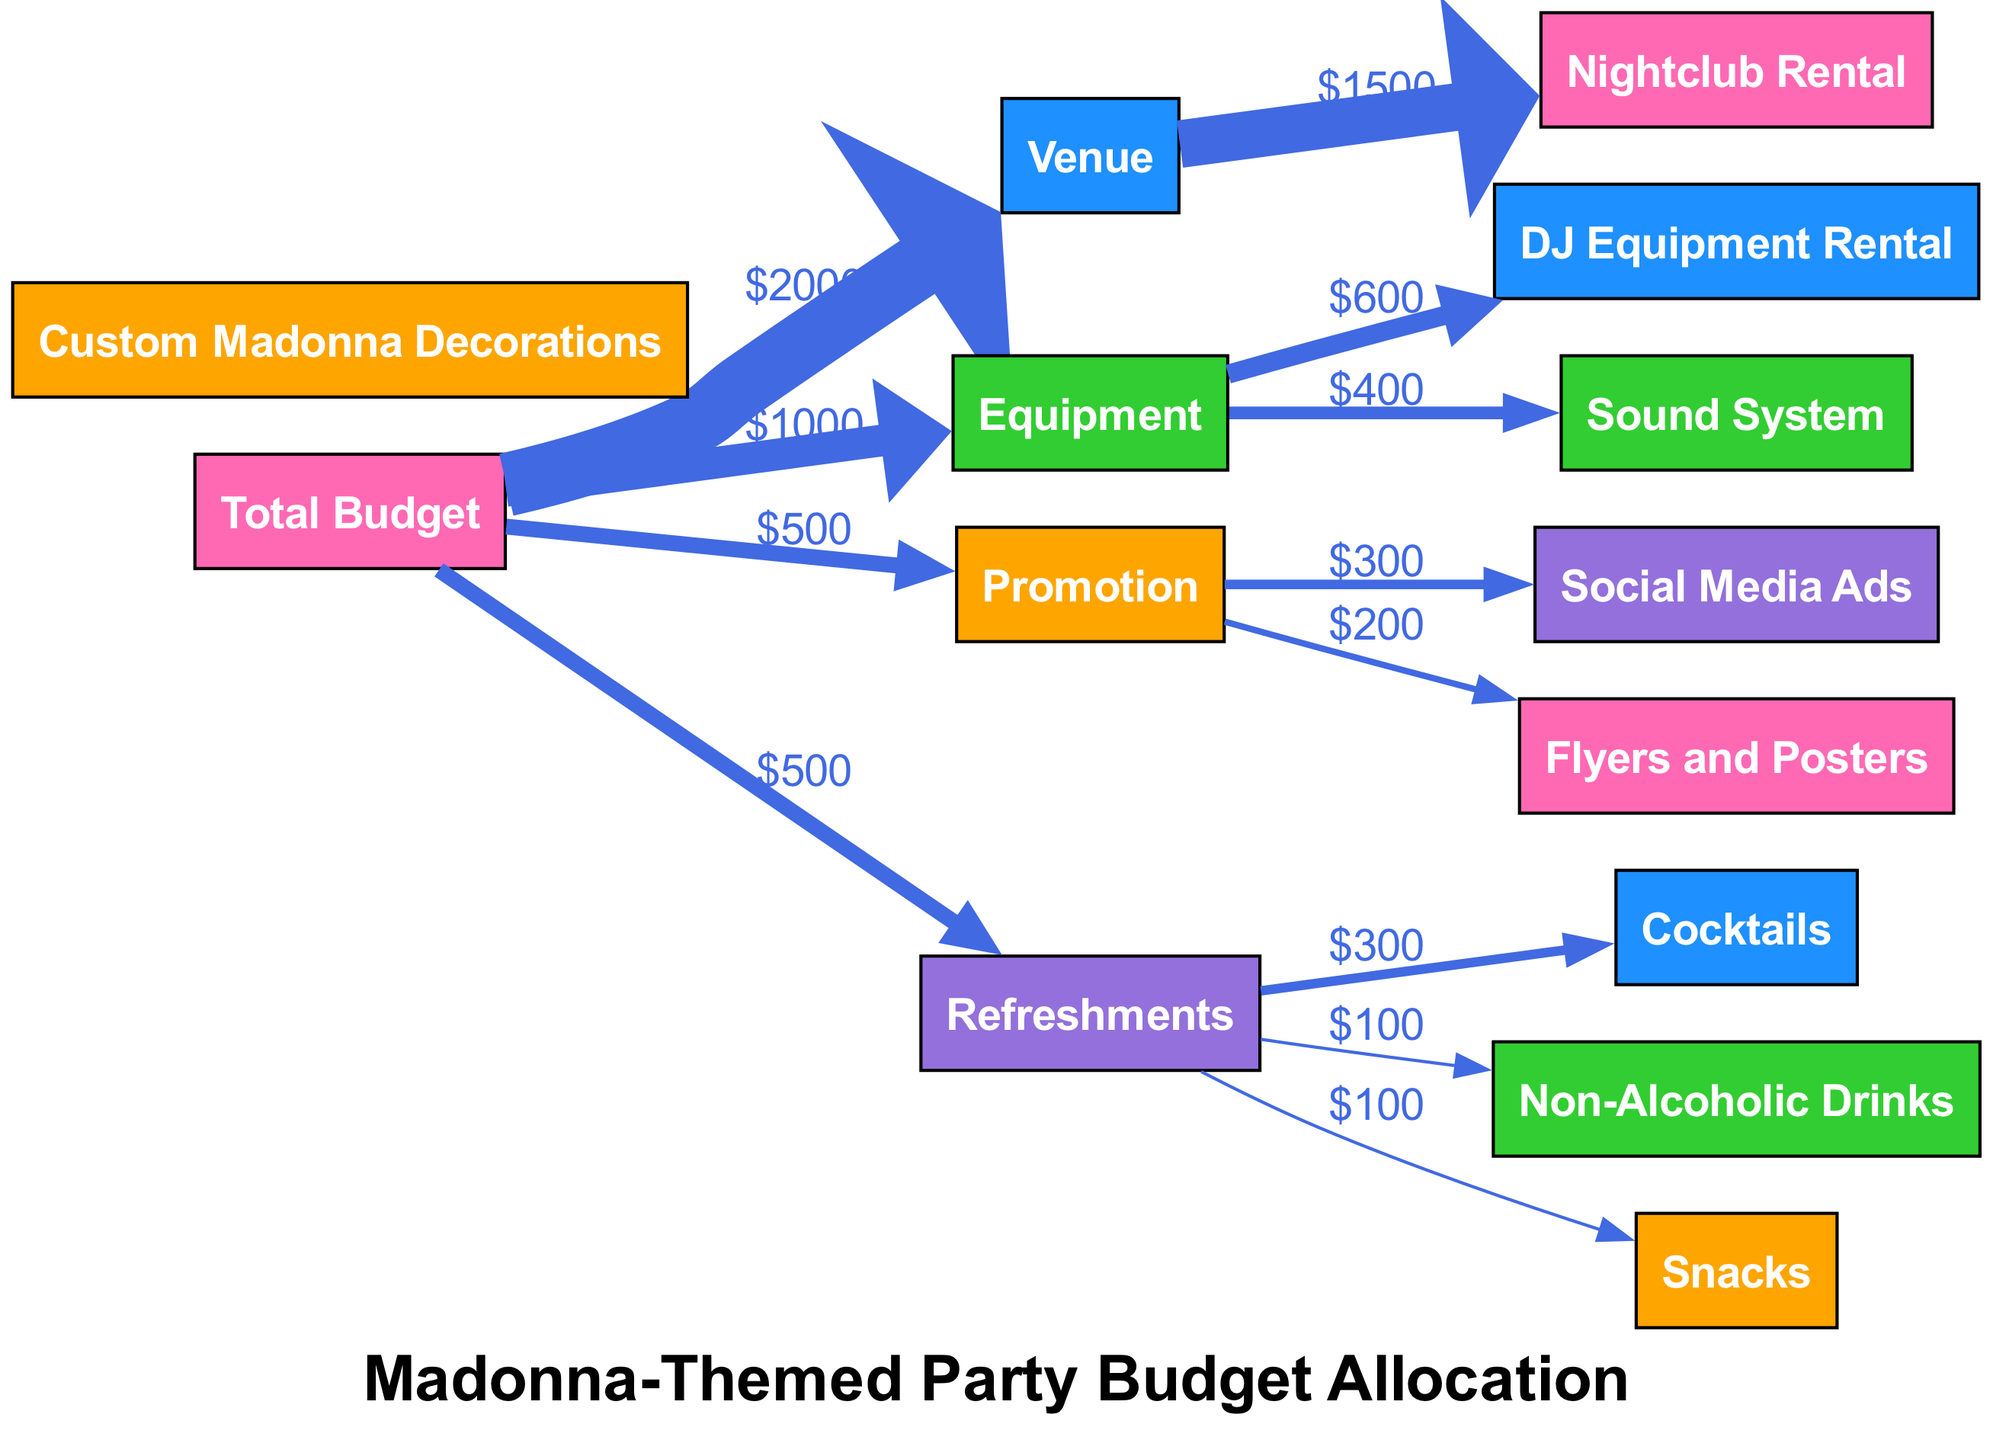What is the total budget allocated for the party? The total budget node is the starting point of the diagram, and the value associated with it, which can be directly observed, is the total budget of two thousand dollars.
Answer: two thousand How much is allocated for venue rental? The arrows lead from the total budget node to the venue node, and it shows that the value allocated for the venue is two thousand dollars, which breaks down further into nightclub rental.
Answer: two thousand What percentage of the total budget is spent on promotion? To find the percentage, we notice that the total budget is two thousand dollars, and the value for promotion is five hundred dollars. The calculation for the percentage is (500 / 2000) * 100, which gives us twenty-five percent.
Answer: twenty-five percent Which category has the largest allocation? By examining the arrows from the total budget, we find that the venue has the highest allocation of two thousand dollars compared to other categories such as equipment, promotion, and refreshments.
Answer: venue How much is spent on social media ads? The promotion category connects to social media ads, which shows that the amount allocated to this node is three hundred dollars, as indicated by the arrow linking these two nodes.
Answer: three hundred What is the total amount allocated for refreshments? The arrow from the total budget to the refreshments category shows a total allocation of five hundred dollars. This total is composed of three further expenses for cocktails, non-alcoholic drinks, and snacks.
Answer: five hundred What is the total amount spent on cocktails and snacks combined? First, we see that cocktails are allocated three hundred dollars and snacks are allocated one hundred dollars. By adding these amounts together, we get three hundred plus one hundred resulting in four hundred dollars.
Answer: four hundred How many edges are there connecting to the equipment category? The equipment category has two outgoing edges directed towards DJ equipment rental and sound system, indicating that there are two connections linking it to these expenses.
Answer: two Which category does not have any breakdowns listed? Observing the nodes, the venue category very clearly leads to nightclub rental directly without further breakdown, implying that it does not have sub-allocations like the other categories.
Answer: venue 